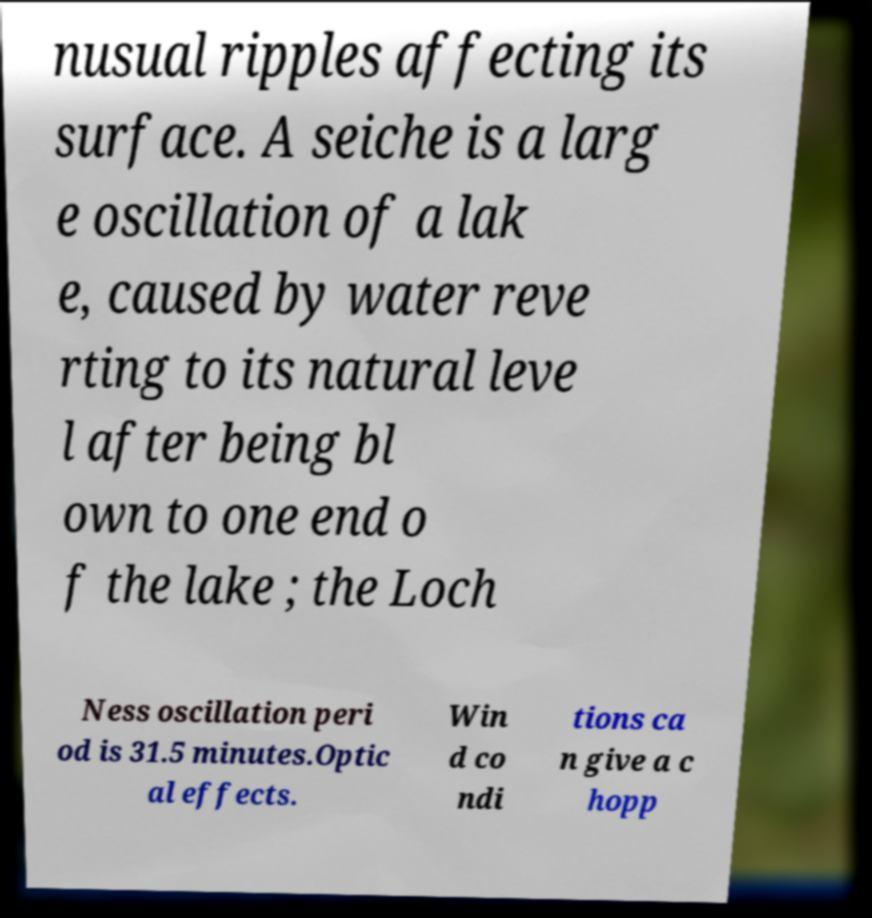Can you read and provide the text displayed in the image?This photo seems to have some interesting text. Can you extract and type it out for me? nusual ripples affecting its surface. A seiche is a larg e oscillation of a lak e, caused by water reve rting to its natural leve l after being bl own to one end o f the lake ; the Loch Ness oscillation peri od is 31.5 minutes.Optic al effects. Win d co ndi tions ca n give a c hopp 